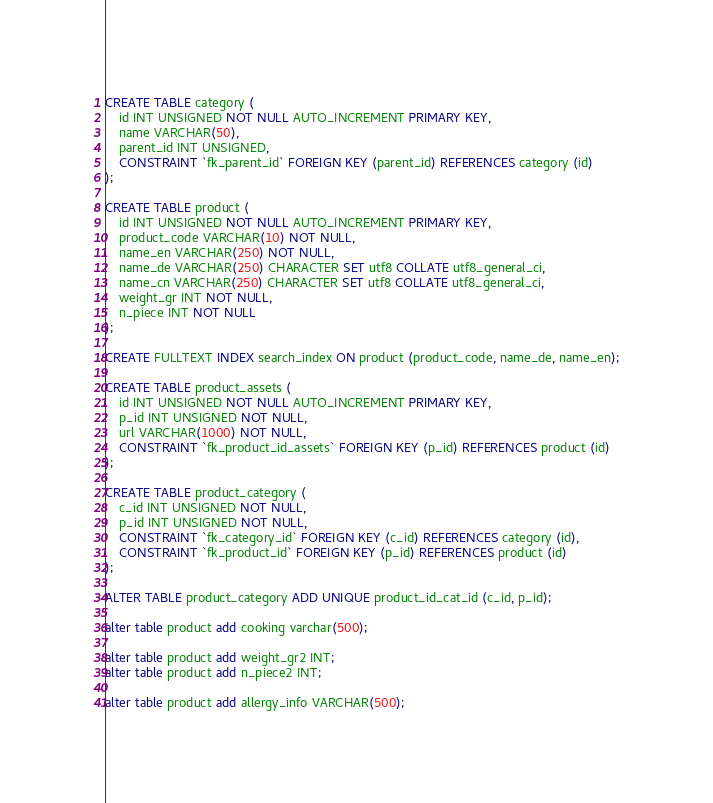<code> <loc_0><loc_0><loc_500><loc_500><_SQL_>CREATE TABLE category (
    id INT UNSIGNED NOT NULL AUTO_INCREMENT PRIMARY KEY, 
    name VARCHAR(50),
    parent_id INT UNSIGNED,
    CONSTRAINT `fk_parent_id` FOREIGN KEY (parent_id) REFERENCES category (id)
);

CREATE TABLE product (
    id INT UNSIGNED NOT NULL AUTO_INCREMENT PRIMARY KEY, 
    product_code VARCHAR(10) NOT NULL,
    name_en VARCHAR(250) NOT NULL,
    name_de VARCHAR(250) CHARACTER SET utf8 COLLATE utf8_general_ci,    
    name_cn VARCHAR(250) CHARACTER SET utf8 COLLATE utf8_general_ci,
    weight_gr INT NOT NULL,
    n_piece INT NOT NULL
);

CREATE FULLTEXT INDEX search_index ON product (product_code, name_de, name_en);

CREATE TABLE product_assets (   
    id INT UNSIGNED NOT NULL AUTO_INCREMENT PRIMARY KEY, 
    p_id INT UNSIGNED NOT NULL,
    url VARCHAR(1000) NOT NULL,
    CONSTRAINT `fk_product_id_assets` FOREIGN KEY (p_id) REFERENCES product (id)
);

CREATE TABLE product_category (
    c_id INT UNSIGNED NOT NULL,
    p_id INT UNSIGNED NOT NULL,
    CONSTRAINT `fk_category_id` FOREIGN KEY (c_id) REFERENCES category (id),
    CONSTRAINT `fk_product_id` FOREIGN KEY (p_id) REFERENCES product (id)
);

ALTER TABLE product_category ADD UNIQUE product_id_cat_id (c_id, p_id);

alter table product add cooking varchar(500);

alter table product add weight_gr2 INT;
alter table product add n_piece2 INT;

alter table product add allergy_info VARCHAR(500);</code> 